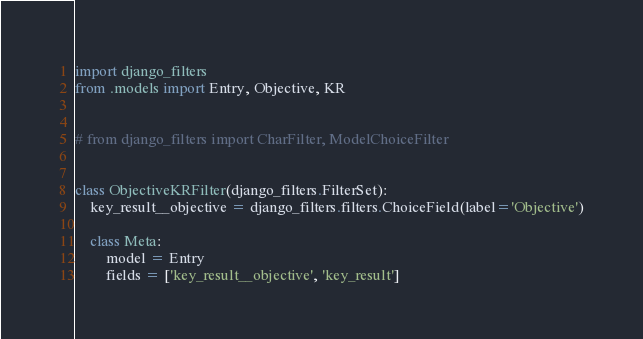Convert code to text. <code><loc_0><loc_0><loc_500><loc_500><_Python_>import django_filters
from .models import Entry, Objective, KR


# from django_filters import CharFilter, ModelChoiceFilter


class ObjectiveKRFilter(django_filters.FilterSet):
    key_result__objective = django_filters.filters.ChoiceField(label='Objective')

    class Meta:
        model = Entry
        fields = ['key_result__objective', 'key_result']
</code> 